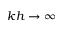Convert formula to latex. <formula><loc_0><loc_0><loc_500><loc_500>k h \rightarrow \infty</formula> 